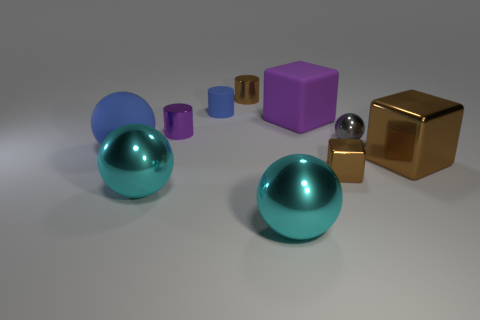How many objects are small spheres or blocks right of the big purple matte thing?
Your response must be concise. 3. There is a thing that is behind the small rubber thing; does it have the same color as the large matte ball?
Provide a short and direct response. No. Are there more big shiny objects that are left of the tiny gray thing than metal spheres that are to the left of the purple shiny thing?
Provide a short and direct response. Yes. Are there any other things that are the same color as the big rubber ball?
Your answer should be compact. Yes. How many objects are gray metallic things or small cyan matte spheres?
Your response must be concise. 1. Is the size of the metallic ball that is right of the purple rubber thing the same as the large brown object?
Give a very brief answer. No. What number of other objects are there of the same size as the blue rubber sphere?
Make the answer very short. 4. Are there any matte blocks?
Offer a very short reply. Yes. There is a metal object that is in front of the large cyan thing left of the blue cylinder; what size is it?
Offer a terse response. Large. There is a shiny ball that is right of the small metallic cube; does it have the same color as the small thing in front of the blue sphere?
Keep it short and to the point. No. 